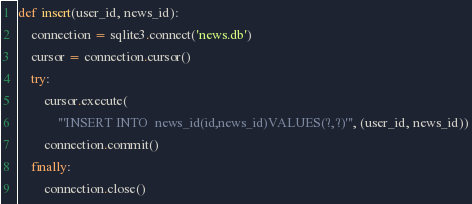<code> <loc_0><loc_0><loc_500><loc_500><_Python_>
def insert(user_id, news_id):
    connection = sqlite3.connect('news.db')
    cursor = connection.cursor()
    try:
        cursor.execute(
            '''INSERT INTO  news_id(id,news_id)VALUES(?,?)''', (user_id, news_id))
        connection.commit()
    finally:
        connection.close()
</code> 